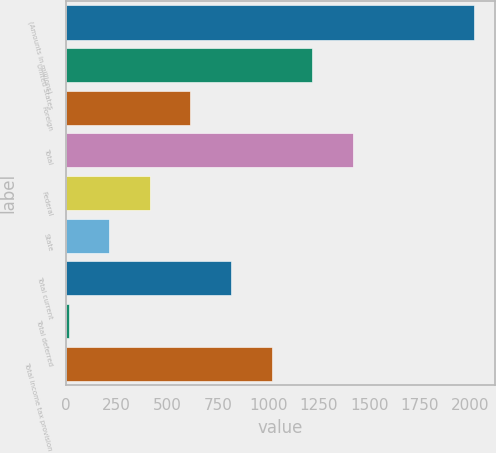Convert chart. <chart><loc_0><loc_0><loc_500><loc_500><bar_chart><fcel>(Amounts in millions)<fcel>United States<fcel>Foreign<fcel>Total<fcel>Federal<fcel>State<fcel>Total current<fcel>Total deferred<fcel>Total income tax provision<nl><fcel>2018<fcel>1216.28<fcel>614.99<fcel>1416.71<fcel>414.56<fcel>214.13<fcel>815.42<fcel>13.7<fcel>1015.85<nl></chart> 